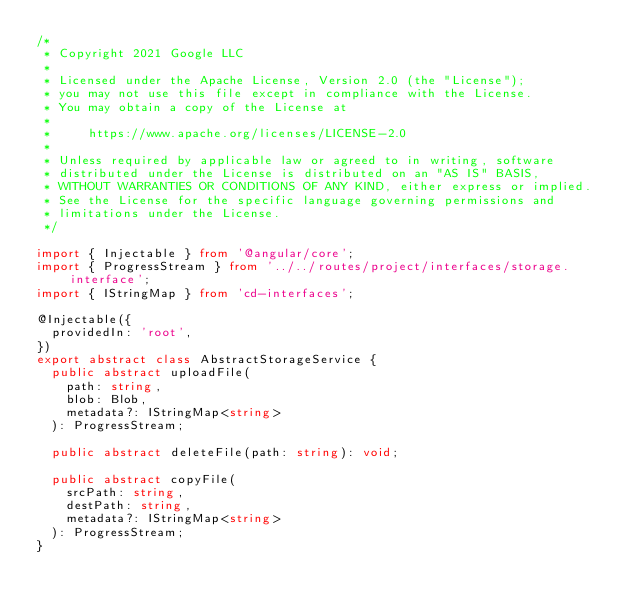<code> <loc_0><loc_0><loc_500><loc_500><_TypeScript_>/*
 * Copyright 2021 Google LLC
 *
 * Licensed under the Apache License, Version 2.0 (the "License");
 * you may not use this file except in compliance with the License.
 * You may obtain a copy of the License at
 *
 *     https://www.apache.org/licenses/LICENSE-2.0
 *
 * Unless required by applicable law or agreed to in writing, software
 * distributed under the License is distributed on an "AS IS" BASIS,
 * WITHOUT WARRANTIES OR CONDITIONS OF ANY KIND, either express or implied.
 * See the License for the specific language governing permissions and
 * limitations under the License.
 */

import { Injectable } from '@angular/core';
import { ProgressStream } from '../../routes/project/interfaces/storage.interface';
import { IStringMap } from 'cd-interfaces';

@Injectable({
  providedIn: 'root',
})
export abstract class AbstractStorageService {
  public abstract uploadFile(
    path: string,
    blob: Blob,
    metadata?: IStringMap<string>
  ): ProgressStream;

  public abstract deleteFile(path: string): void;

  public abstract copyFile(
    srcPath: string,
    destPath: string,
    metadata?: IStringMap<string>
  ): ProgressStream;
}
</code> 